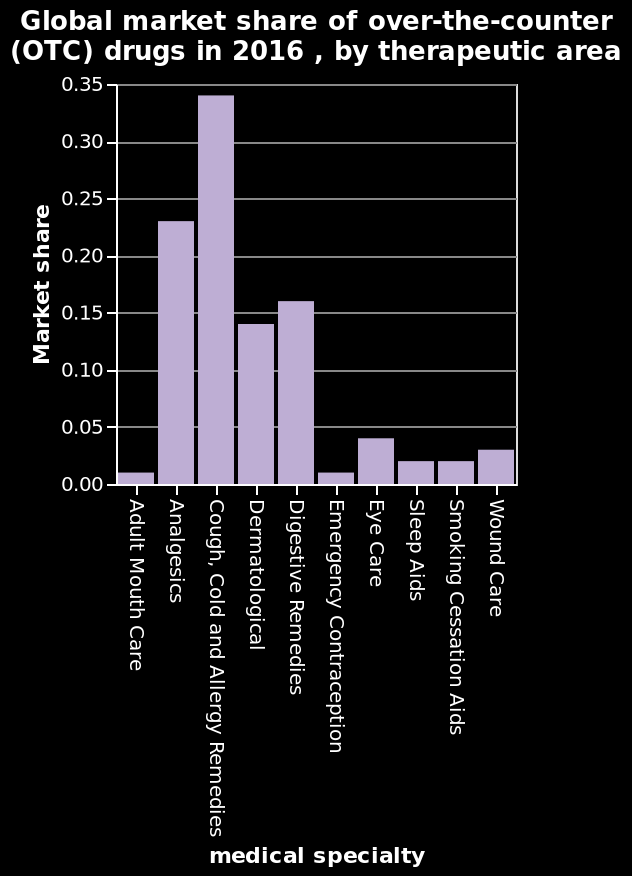<image>
What was the global market share of over-the-counter drugs for Wound Care in 2016? The global market share of over-the-counter drugs for Wound Care in 2016 is not specified in the given information. What was the market share for cough, cold, and allergy remedies?  The market share for cough, cold, and allergy remedies was 0.34. What does the x-axis measure on the bar graph? The x-axis on the bar graph measures the medical specialty, ranging from Adult Mouth Care to Wound Care on a categorical scale. Which therapeutic area had the highest market share of over-the-counter drugs in 2016? The therapeutic area with the highest market share of over-the-counter drugs in 2016 is not specified in the given information. please describe the details of the chart Global market share of over-the-counter (OTC) drugs in 2016 , by therapeutic area is a bar graph. The y-axis plots Market share on scale of range 0.00 to 0.35 while the x-axis measures medical specialty using categorical scale from Adult Mouth Care to Wound Care. 